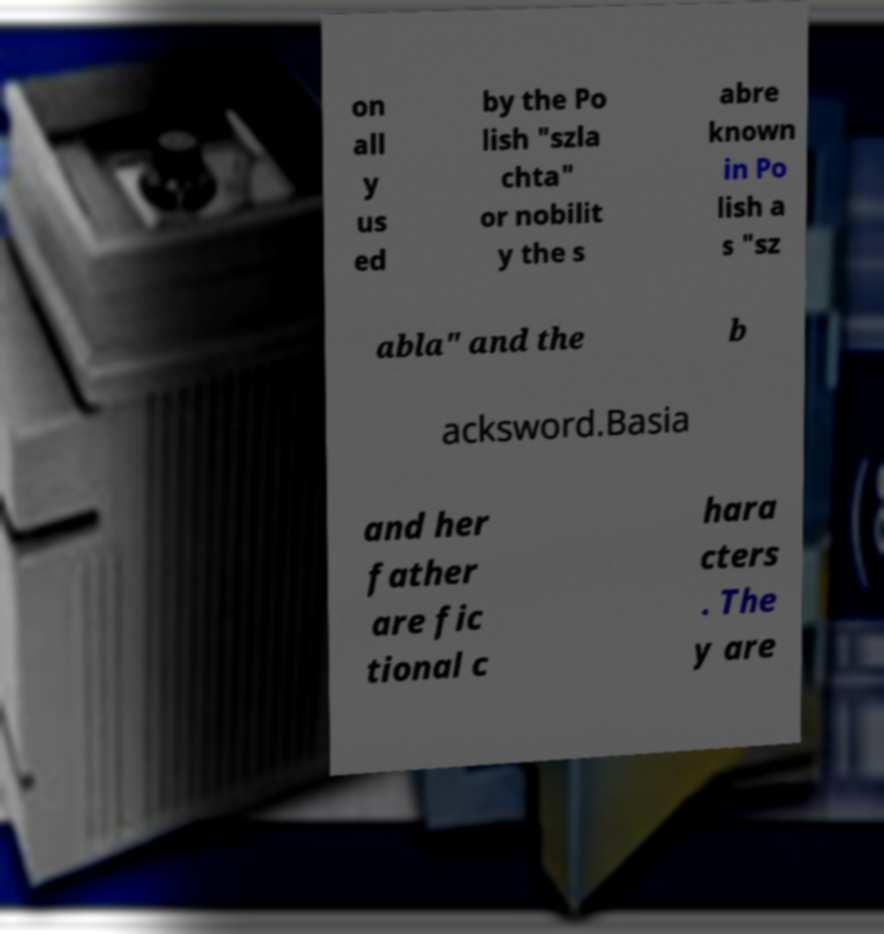For documentation purposes, I need the text within this image transcribed. Could you provide that? on all y us ed by the Po lish "szla chta" or nobilit y the s abre known in Po lish a s "sz abla" and the b acksword.Basia and her father are fic tional c hara cters . The y are 